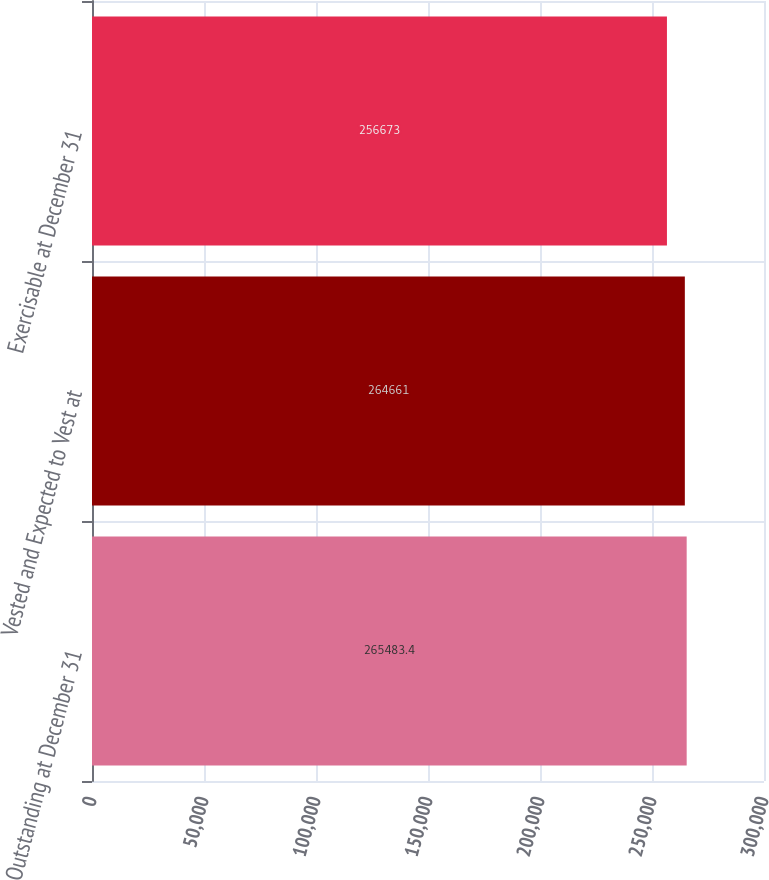<chart> <loc_0><loc_0><loc_500><loc_500><bar_chart><fcel>Outstanding at December 31<fcel>Vested and Expected to Vest at<fcel>Exercisable at December 31<nl><fcel>265483<fcel>264661<fcel>256673<nl></chart> 